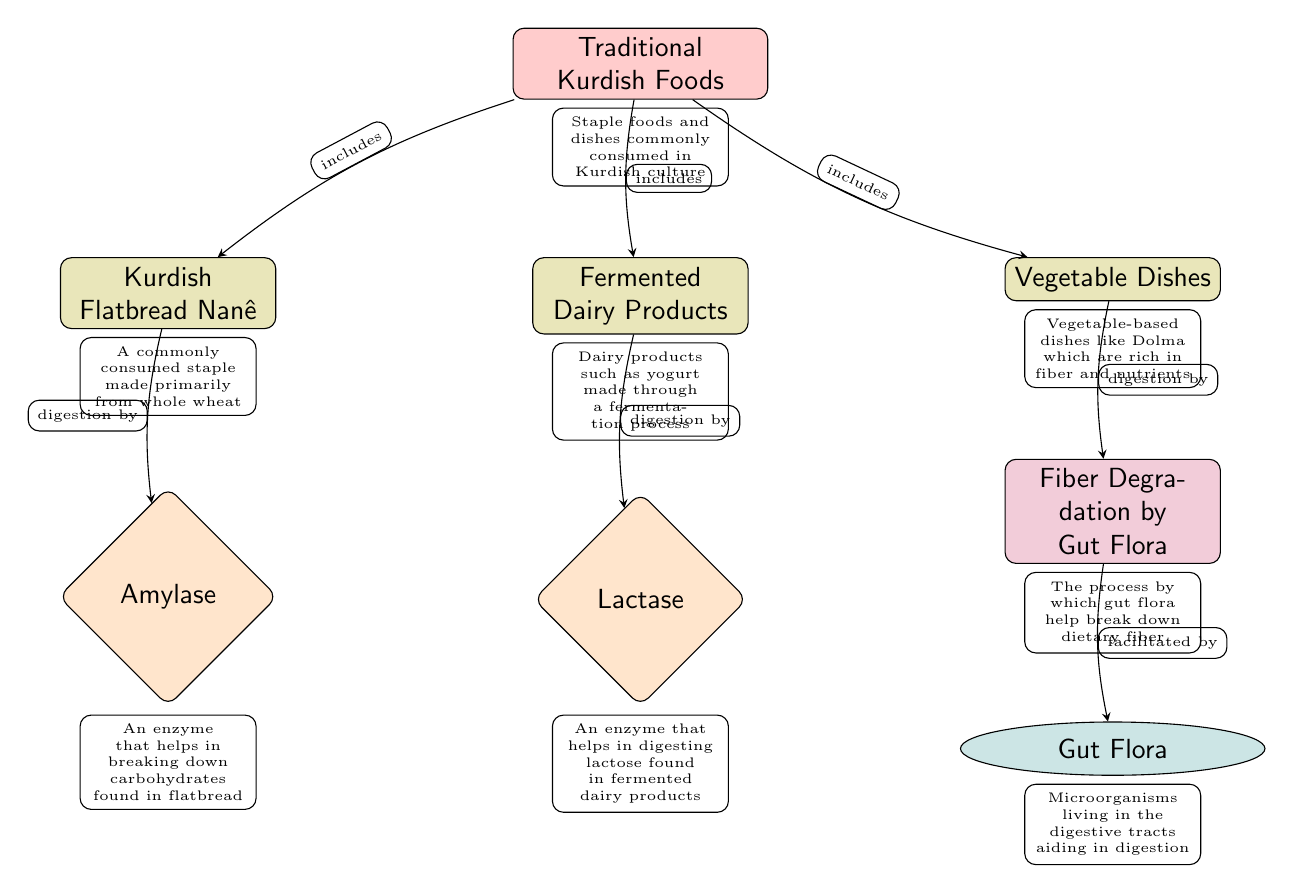What is the main topic of the diagram? The main topic is indicated by the central node labeled "Traditional Kurdish Foods". This node serves as the focal point from which various foods and their interactions with digestive enzymes and gut flora stem.
Answer: Traditional Kurdish Foods How many different types of food are included in the diagram? The diagram includes three different types of food nodes: "Kurdish Flatbread Nanê", "Fermented Dairy Products", and "Vegetable Dishes". By counting these nodes, we determine the total number of food types.
Answer: 3 Which enzyme is associated with Kurdish Flatbread Nanê? The diagram shows that "Amylase" is connected to "Kurdish Flatbread Nanê" through an edge. This relationship indicates that amylase is the enzyme responsible for digesting the carbohydrates in flatbread.
Answer: Amylase What process is facilitated by gut flora according to the diagram? The process mentioned in the diagram is "Fiber Degradation by Gut Flora". This indicates that gut flora plays a role in breaking down dietary fiber. By following the connections in the diagram, we can identify this specific process.
Answer: Fiber Degradation by Gut Flora What enzyme is responsible for digesting lactose? The node labeled "Lactase" is directly connected to "Fermented Dairy Products," indicating that lactase is the enzyme that digests lactose found in these dairy products. The connection clearly states the function of this enzyme.
Answer: Lactase What is the relationship between Vegetable Dishes and Gut Flora? "Vegetable Dishes" connects to "Fiber Degradation by Gut Flora", and there is a further connection showing that gut flora facilitate this degradation process. Thus, the relationship is that vegetable dishes lead to the activity of gut flora in breaking down fiber.
Answer: Gut Flora facilitate fiber degradation How many edges connect to the main node? The main node, "Traditional Kurdish Foods", has three edges that connect it to the food nodes: "Kurdish Flatbread Nanê", "Fermented Dairy Products", and "Vegetable Dishes". By analyzing the connections, we see there are three distinct relationships to the main topic.
Answer: 3 What types of dishes are categorized under fermented dairy products? The diagram describes "Fermented Dairy Products" as encompassing yogurt made through a fermentation process. This gives us a specific type of dish included within this category.
Answer: Yogurt Which food is primarily made from whole wheat? The node "Kurdish Flatbread Nanê" identifies that it is a staple made primarily from whole wheat. This information is highlighted in the node itself.
Answer: Kurdish Flatbread Nanê 